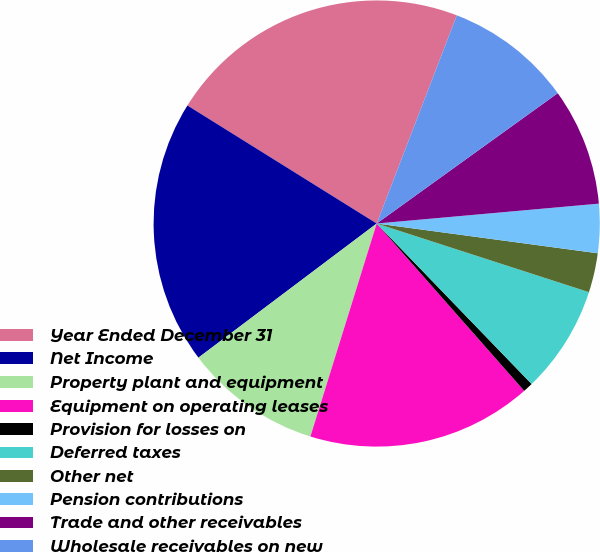<chart> <loc_0><loc_0><loc_500><loc_500><pie_chart><fcel>Year Ended December 31<fcel>Net Income<fcel>Property plant and equipment<fcel>Equipment on operating leases<fcel>Provision for losses on<fcel>Deferred taxes<fcel>Other net<fcel>Pension contributions<fcel>Trade and other receivables<fcel>Wholesale receivables on new<nl><fcel>21.97%<fcel>19.14%<fcel>9.93%<fcel>16.3%<fcel>0.72%<fcel>7.8%<fcel>2.85%<fcel>3.55%<fcel>8.51%<fcel>9.22%<nl></chart> 